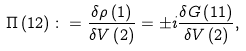<formula> <loc_0><loc_0><loc_500><loc_500>\Pi \left ( 1 2 \right ) \colon = \frac { \delta \rho \left ( 1 \right ) } { \delta V \left ( 2 \right ) } = \pm i \frac { \delta G \left ( 1 1 \right ) } { \delta V \left ( 2 \right ) } ,</formula> 